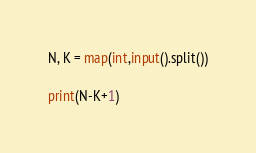Convert code to text. <code><loc_0><loc_0><loc_500><loc_500><_Python_>N, K = map(int,input().split())

print(N-K+1)</code> 